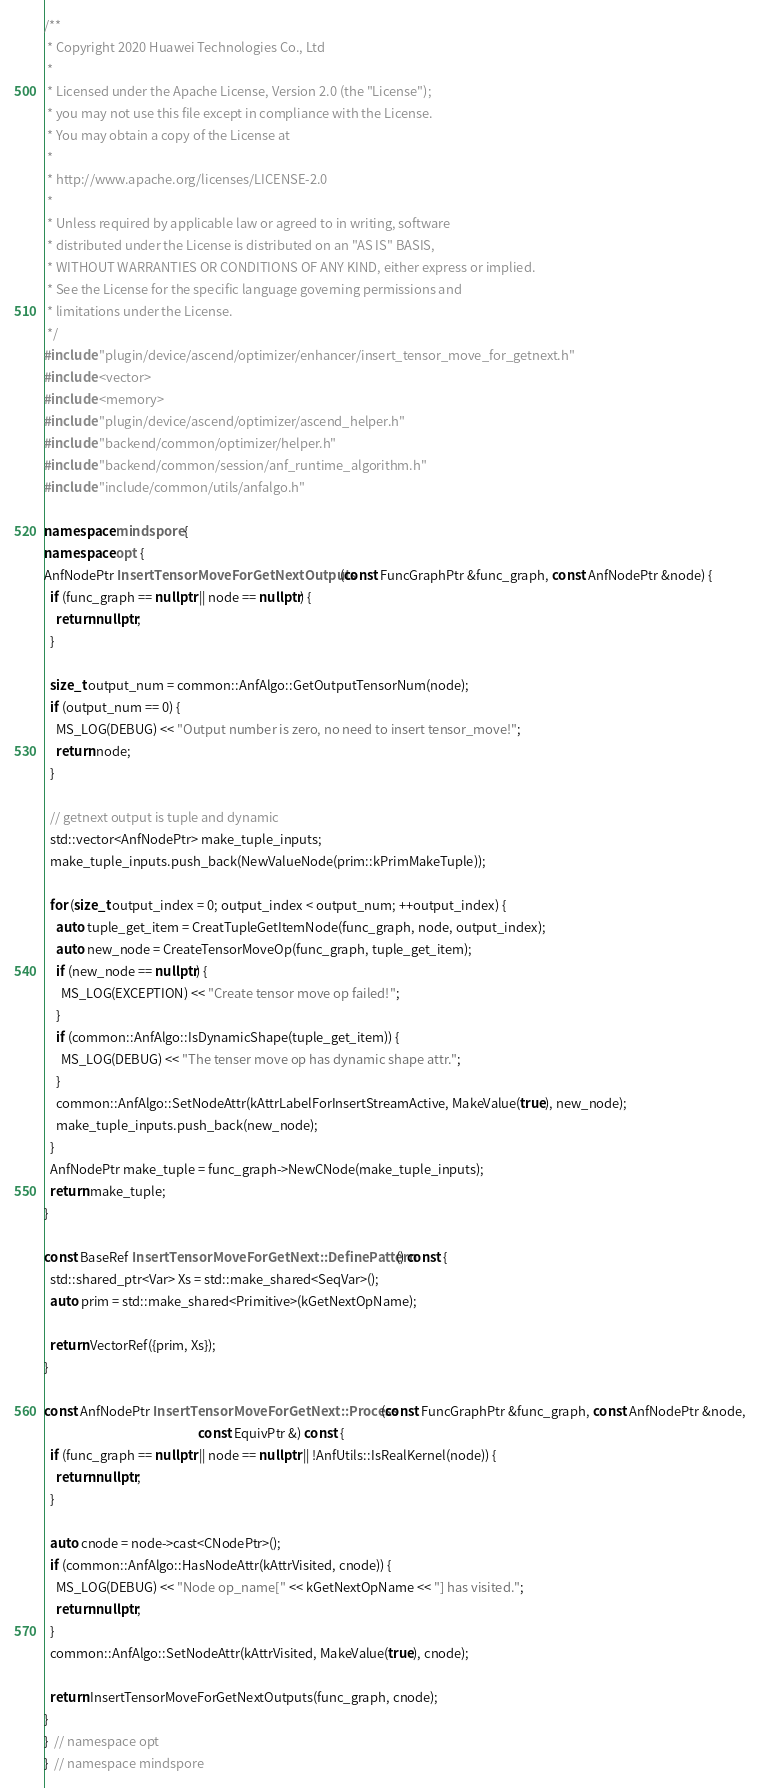<code> <loc_0><loc_0><loc_500><loc_500><_C++_>/**
 * Copyright 2020 Huawei Technologies Co., Ltd
 *
 * Licensed under the Apache License, Version 2.0 (the "License");
 * you may not use this file except in compliance with the License.
 * You may obtain a copy of the License at
 *
 * http://www.apache.org/licenses/LICENSE-2.0
 *
 * Unless required by applicable law or agreed to in writing, software
 * distributed under the License is distributed on an "AS IS" BASIS,
 * WITHOUT WARRANTIES OR CONDITIONS OF ANY KIND, either express or implied.
 * See the License for the specific language governing permissions and
 * limitations under the License.
 */
#include "plugin/device/ascend/optimizer/enhancer/insert_tensor_move_for_getnext.h"
#include <vector>
#include <memory>
#include "plugin/device/ascend/optimizer/ascend_helper.h"
#include "backend/common/optimizer/helper.h"
#include "backend/common/session/anf_runtime_algorithm.h"
#include "include/common/utils/anfalgo.h"

namespace mindspore {
namespace opt {
AnfNodePtr InsertTensorMoveForGetNextOutputs(const FuncGraphPtr &func_graph, const AnfNodePtr &node) {
  if (func_graph == nullptr || node == nullptr) {
    return nullptr;
  }

  size_t output_num = common::AnfAlgo::GetOutputTensorNum(node);
  if (output_num == 0) {
    MS_LOG(DEBUG) << "Output number is zero, no need to insert tensor_move!";
    return node;
  }

  // getnext output is tuple and dynamic
  std::vector<AnfNodePtr> make_tuple_inputs;
  make_tuple_inputs.push_back(NewValueNode(prim::kPrimMakeTuple));

  for (size_t output_index = 0; output_index < output_num; ++output_index) {
    auto tuple_get_item = CreatTupleGetItemNode(func_graph, node, output_index);
    auto new_node = CreateTensorMoveOp(func_graph, tuple_get_item);
    if (new_node == nullptr) {
      MS_LOG(EXCEPTION) << "Create tensor move op failed!";
    }
    if (common::AnfAlgo::IsDynamicShape(tuple_get_item)) {
      MS_LOG(DEBUG) << "The tenser move op has dynamic shape attr.";
    }
    common::AnfAlgo::SetNodeAttr(kAttrLabelForInsertStreamActive, MakeValue(true), new_node);
    make_tuple_inputs.push_back(new_node);
  }
  AnfNodePtr make_tuple = func_graph->NewCNode(make_tuple_inputs);
  return make_tuple;
}

const BaseRef InsertTensorMoveForGetNext::DefinePattern() const {
  std::shared_ptr<Var> Xs = std::make_shared<SeqVar>();
  auto prim = std::make_shared<Primitive>(kGetNextOpName);

  return VectorRef({prim, Xs});
}

const AnfNodePtr InsertTensorMoveForGetNext::Process(const FuncGraphPtr &func_graph, const AnfNodePtr &node,
                                                     const EquivPtr &) const {
  if (func_graph == nullptr || node == nullptr || !AnfUtils::IsRealKernel(node)) {
    return nullptr;
  }

  auto cnode = node->cast<CNodePtr>();
  if (common::AnfAlgo::HasNodeAttr(kAttrVisited, cnode)) {
    MS_LOG(DEBUG) << "Node op_name[" << kGetNextOpName << "] has visited.";
    return nullptr;
  }
  common::AnfAlgo::SetNodeAttr(kAttrVisited, MakeValue(true), cnode);

  return InsertTensorMoveForGetNextOutputs(func_graph, cnode);
}
}  // namespace opt
}  // namespace mindspore
</code> 